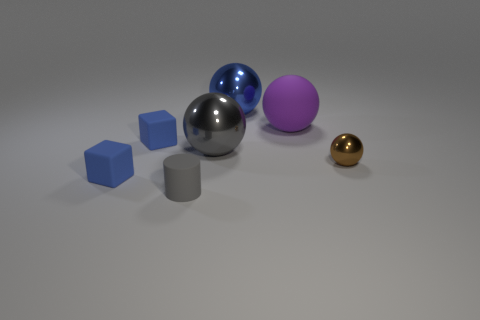What number of cubes are tiny blue matte objects or big gray metal objects?
Provide a short and direct response. 2. There is a small blue thing in front of the brown thing; what material is it?
Offer a very short reply. Rubber. What size is the thing that is the same color as the tiny cylinder?
Your answer should be compact. Large. Do the matte thing that is on the right side of the blue metallic thing and the large object in front of the rubber sphere have the same color?
Offer a terse response. No. What number of objects are small yellow metallic cubes or small blue cubes?
Provide a succinct answer. 2. How many other objects are there of the same shape as the gray rubber object?
Provide a short and direct response. 0. Does the gray sphere that is behind the gray rubber cylinder have the same material as the cube in front of the small metallic sphere?
Your response must be concise. No. The metallic object that is to the left of the purple matte ball and in front of the large purple matte sphere has what shape?
Provide a succinct answer. Sphere. Is there anything else that has the same material as the brown object?
Your answer should be compact. Yes. There is a thing that is behind the brown metal sphere and on the right side of the blue sphere; what material is it?
Provide a succinct answer. Rubber. 